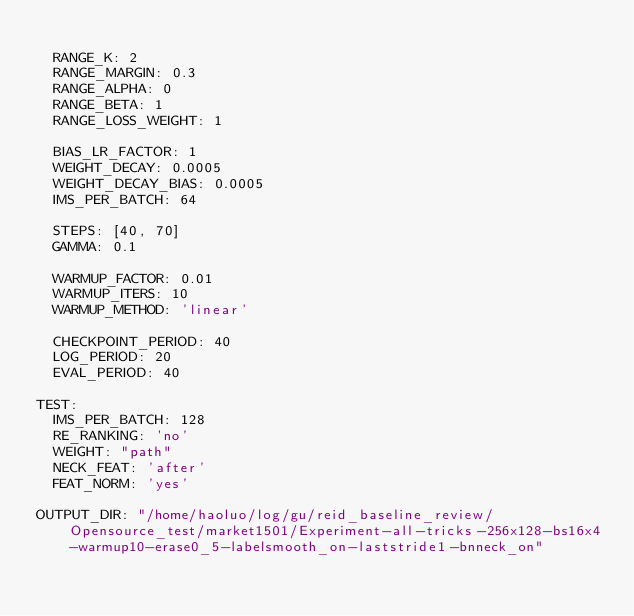Convert code to text. <code><loc_0><loc_0><loc_500><loc_500><_YAML_>
  RANGE_K: 2
  RANGE_MARGIN: 0.3
  RANGE_ALPHA: 0
  RANGE_BETA: 1
  RANGE_LOSS_WEIGHT: 1

  BIAS_LR_FACTOR: 1
  WEIGHT_DECAY: 0.0005
  WEIGHT_DECAY_BIAS: 0.0005
  IMS_PER_BATCH: 64

  STEPS: [40, 70]
  GAMMA: 0.1

  WARMUP_FACTOR: 0.01
  WARMUP_ITERS: 10
  WARMUP_METHOD: 'linear'

  CHECKPOINT_PERIOD: 40
  LOG_PERIOD: 20
  EVAL_PERIOD: 40

TEST:
  IMS_PER_BATCH: 128
  RE_RANKING: 'no'
  WEIGHT: "path"
  NECK_FEAT: 'after'
  FEAT_NORM: 'yes'

OUTPUT_DIR: "/home/haoluo/log/gu/reid_baseline_review/Opensource_test/market1501/Experiment-all-tricks-256x128-bs16x4-warmup10-erase0_5-labelsmooth_on-laststride1-bnneck_on"
</code> 